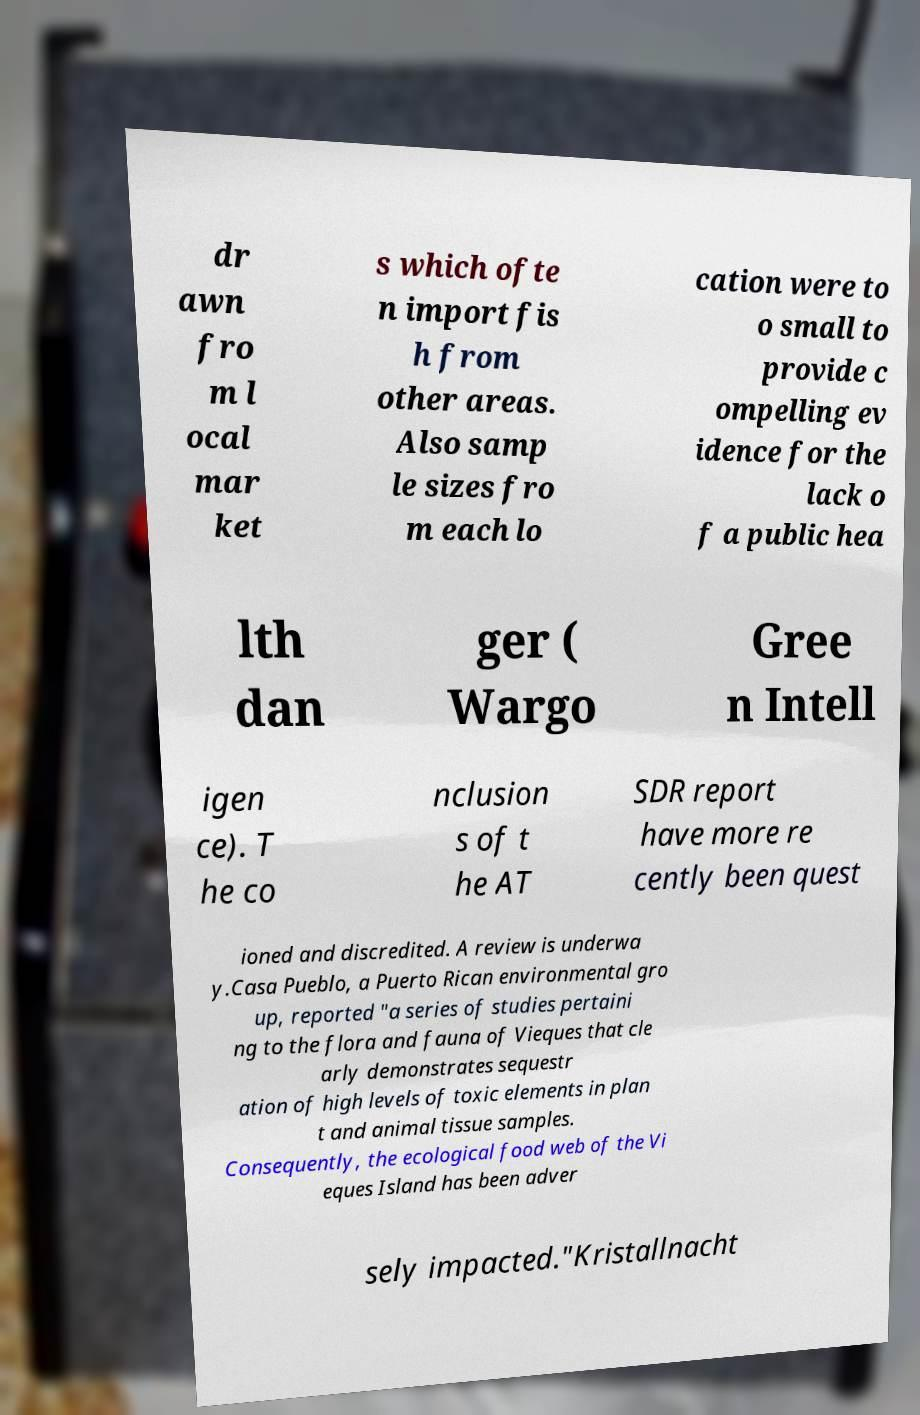What messages or text are displayed in this image? I need them in a readable, typed format. dr awn fro m l ocal mar ket s which ofte n import fis h from other areas. Also samp le sizes fro m each lo cation were to o small to provide c ompelling ev idence for the lack o f a public hea lth dan ger ( Wargo Gree n Intell igen ce). T he co nclusion s of t he AT SDR report have more re cently been quest ioned and discredited. A review is underwa y.Casa Pueblo, a Puerto Rican environmental gro up, reported "a series of studies pertaini ng to the flora and fauna of Vieques that cle arly demonstrates sequestr ation of high levels of toxic elements in plan t and animal tissue samples. Consequently, the ecological food web of the Vi eques Island has been adver sely impacted."Kristallnacht 